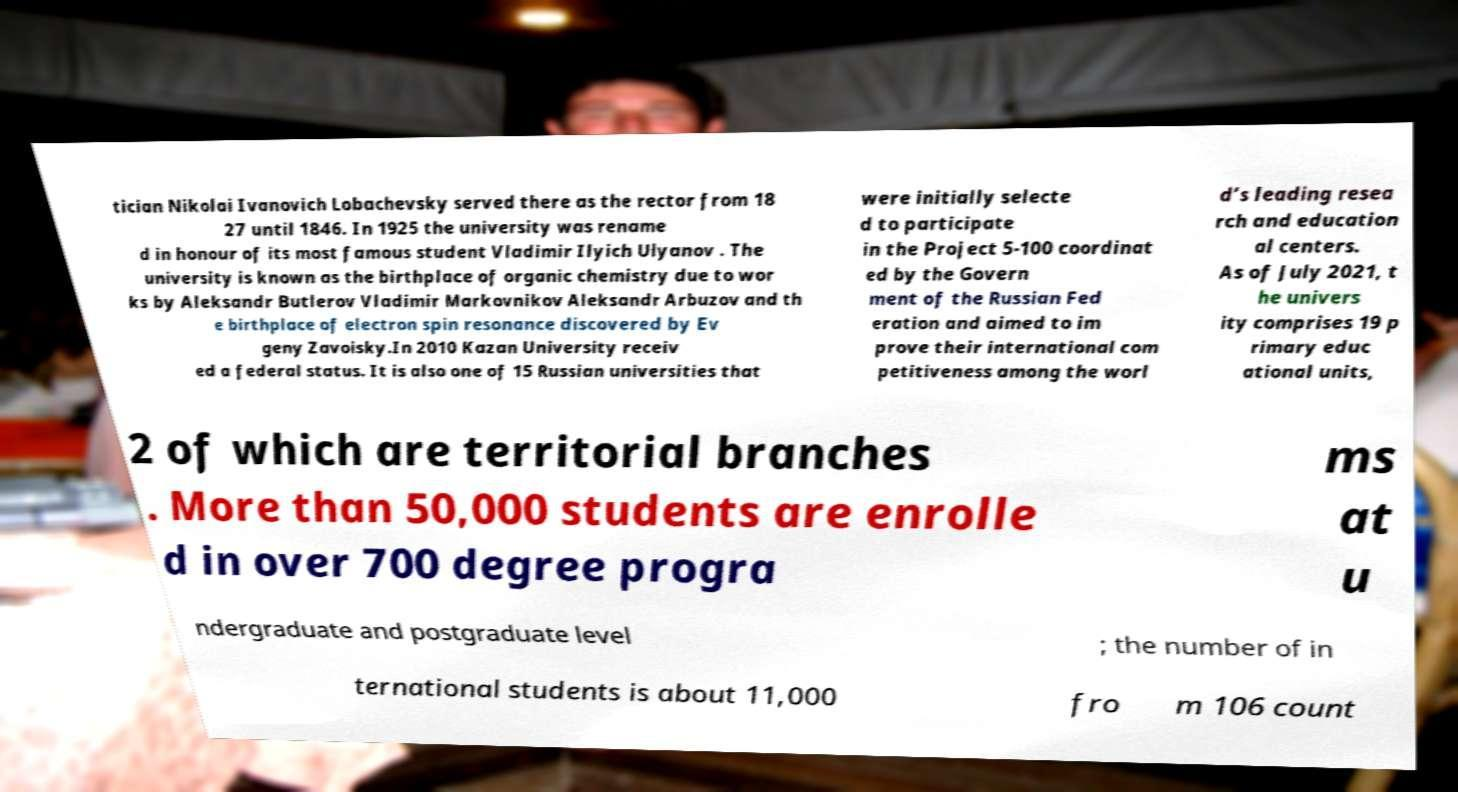Could you extract and type out the text from this image? tician Nikolai Ivanovich Lobachevsky served there as the rector from 18 27 until 1846. In 1925 the university was rename d in honour of its most famous student Vladimir Ilyich Ulyanov . The university is known as the birthplace of organic chemistry due to wor ks by Aleksandr Butlerov Vladimir Markovnikov Aleksandr Arbuzov and th e birthplace of electron spin resonance discovered by Ev geny Zavoisky.In 2010 Kazan University receiv ed a federal status. It is also one of 15 Russian universities that were initially selecte d to participate in the Project 5-100 coordinat ed by the Govern ment of the Russian Fed eration and aimed to im prove their international com petitiveness among the worl d’s leading resea rch and education al centers. As of July 2021, t he univers ity comprises 19 p rimary educ ational units, 2 of which are territorial branches . More than 50,000 students are enrolle d in over 700 degree progra ms at u ndergraduate and postgraduate level ; the number of in ternational students is about 11,000 fro m 106 count 